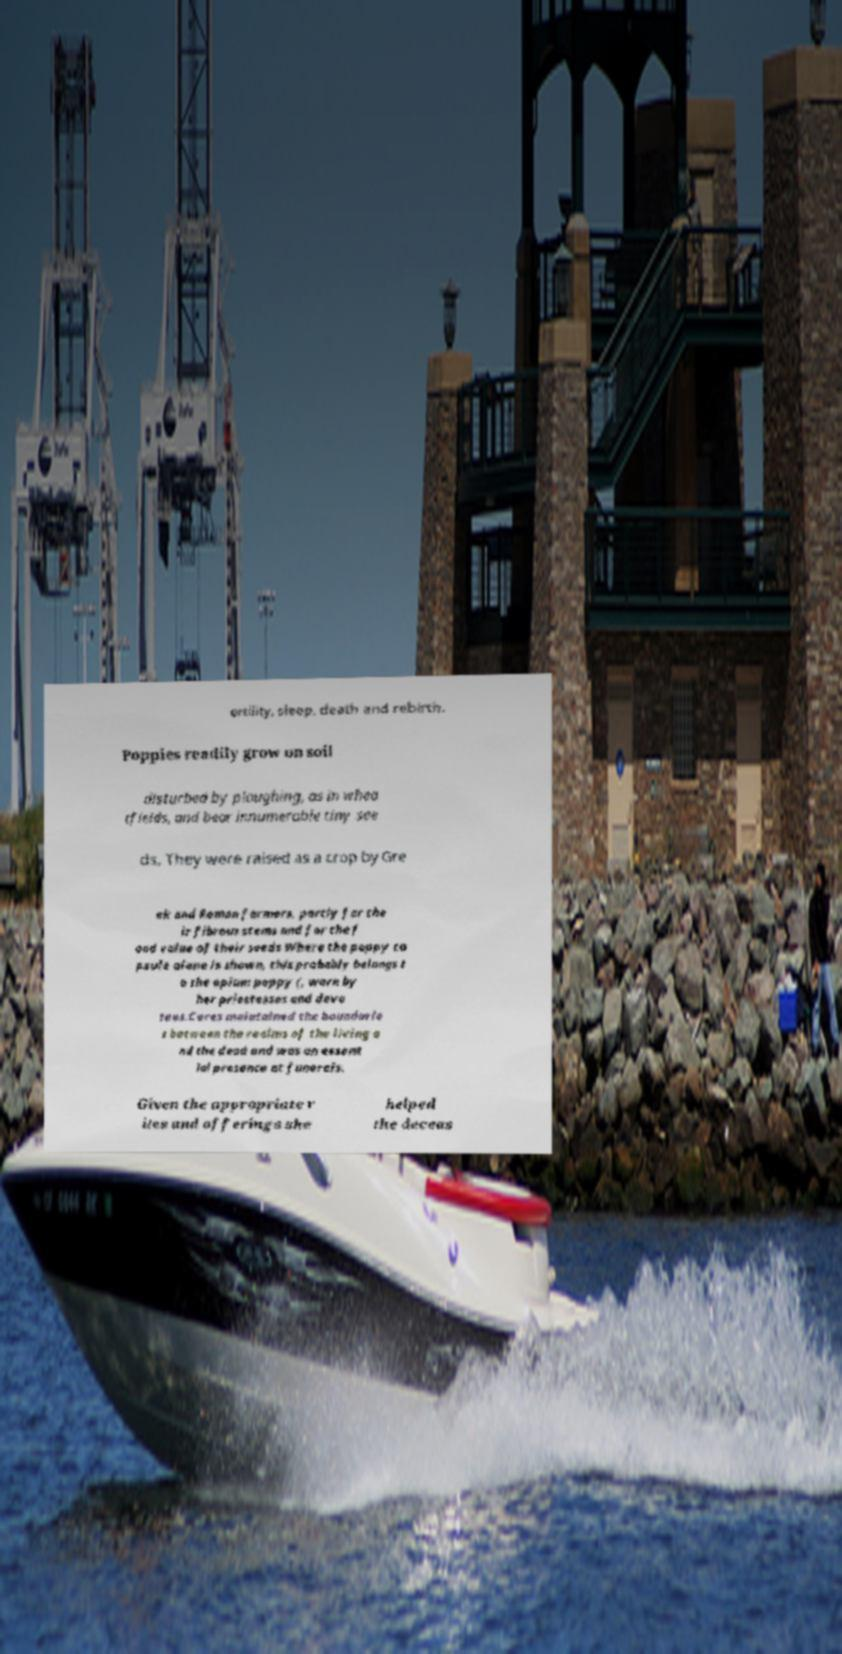Please read and relay the text visible in this image. What does it say? ertility, sleep, death and rebirth. Poppies readily grow on soil disturbed by ploughing, as in whea tfields, and bear innumerable tiny see ds. They were raised as a crop by Gre ek and Roman farmers, partly for the ir fibrous stems and for the f ood value of their seeds Where the poppy ca psule alone is shown, this probably belongs t o the opium poppy (, worn by her priestesses and devo tees.Ceres maintained the boundarie s between the realms of the living a nd the dead and was an essent ial presence at funerals. Given the appropriate r ites and offerings she helped the deceas 